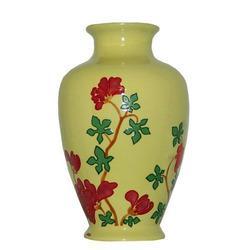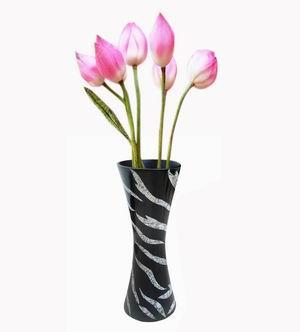The first image is the image on the left, the second image is the image on the right. Examine the images to the left and right. Is the description "There are at most 3 tulips in a glass vase" accurate? Answer yes or no. No. 